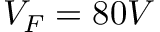<formula> <loc_0><loc_0><loc_500><loc_500>V _ { F } = 8 0 V</formula> 